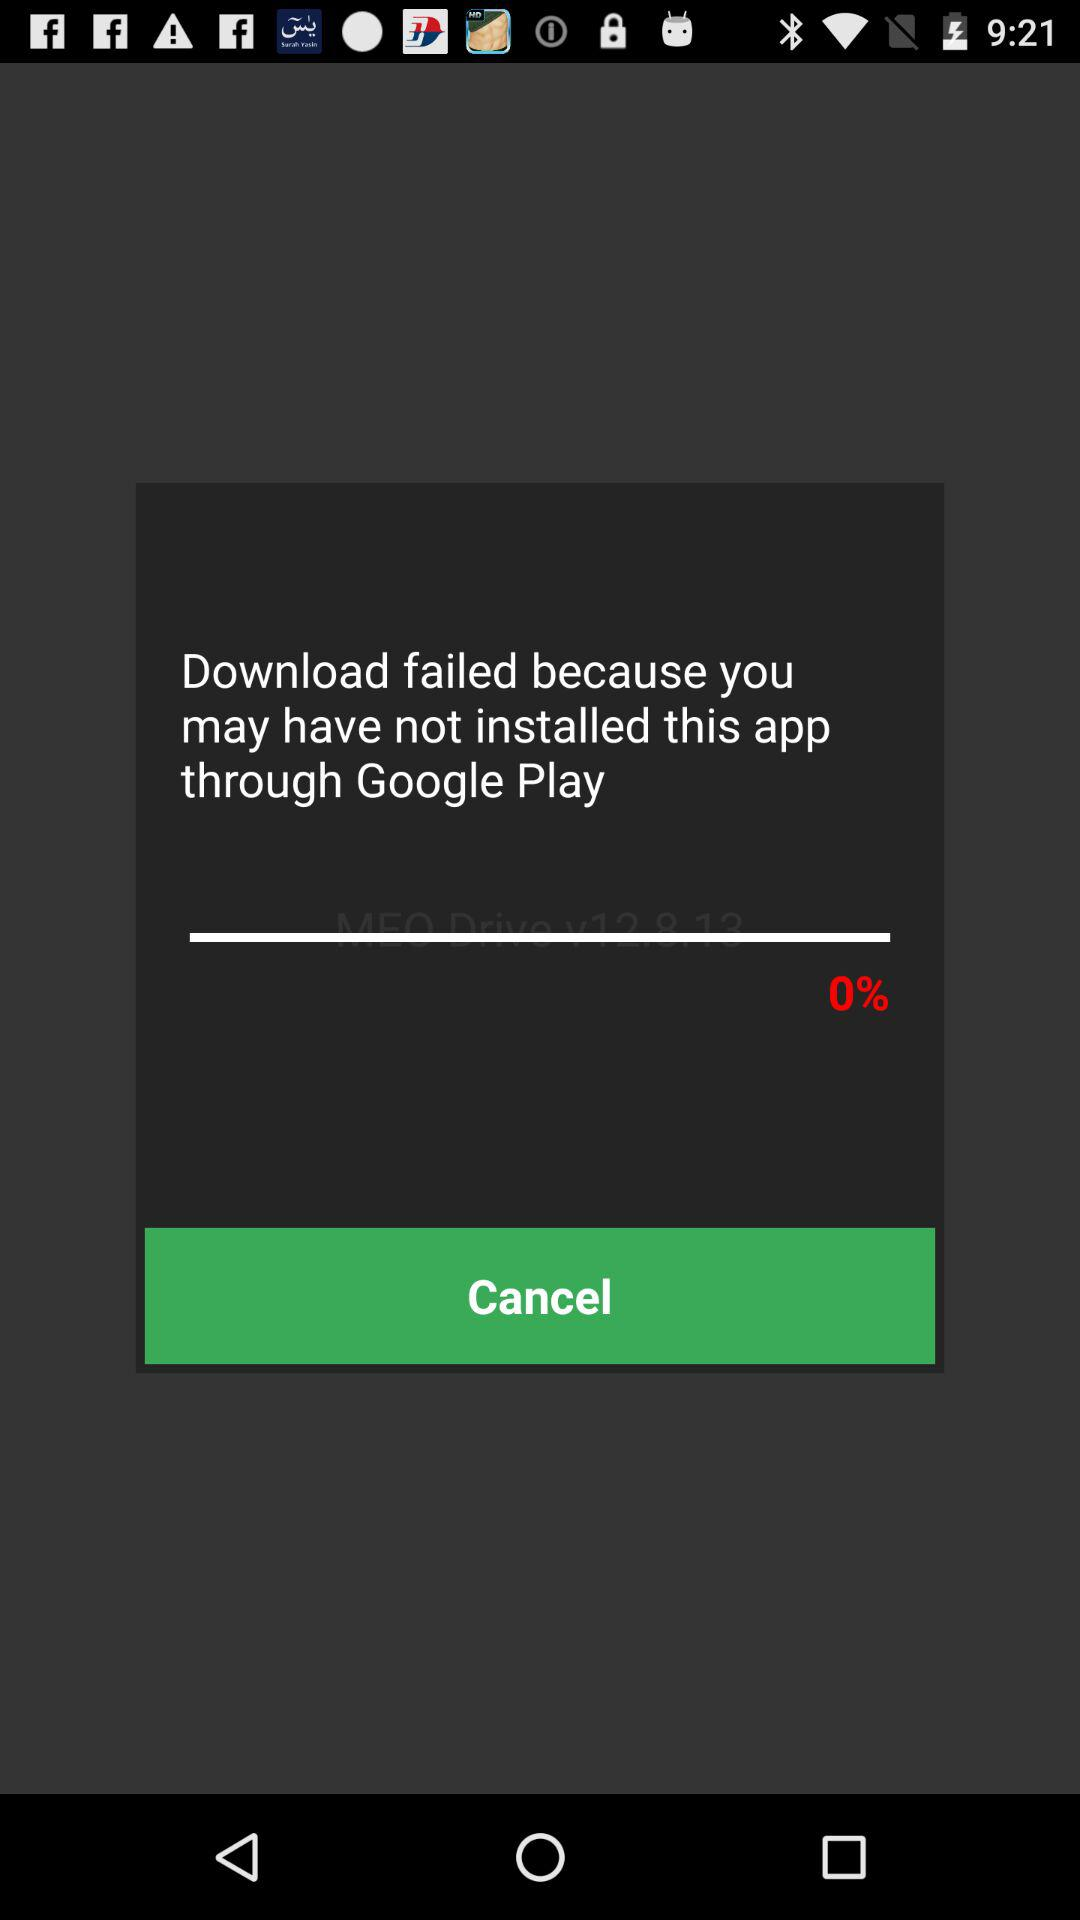How much progress is there on the download?
Answer the question using a single word or phrase. 0% 